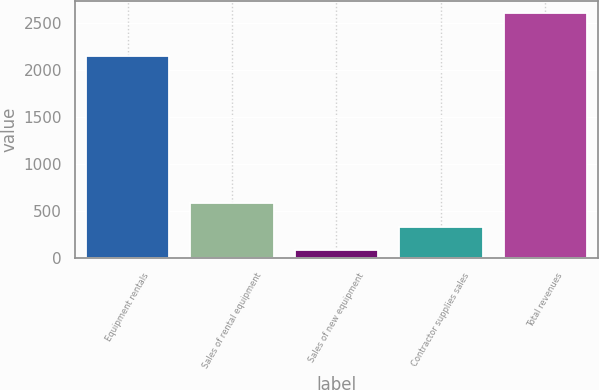Convert chart to OTSL. <chart><loc_0><loc_0><loc_500><loc_500><bar_chart><fcel>Equipment rentals<fcel>Sales of rental equipment<fcel>Sales of new equipment<fcel>Contractor supplies sales<fcel>Total revenues<nl><fcel>2151<fcel>589.4<fcel>84<fcel>336.7<fcel>2611<nl></chart> 